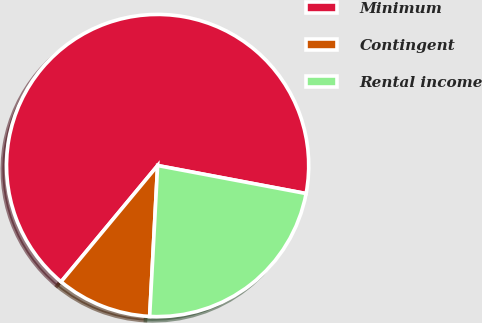Convert chart to OTSL. <chart><loc_0><loc_0><loc_500><loc_500><pie_chart><fcel>Minimum<fcel>Contingent<fcel>Rental income<nl><fcel>66.94%<fcel>10.19%<fcel>22.87%<nl></chart> 